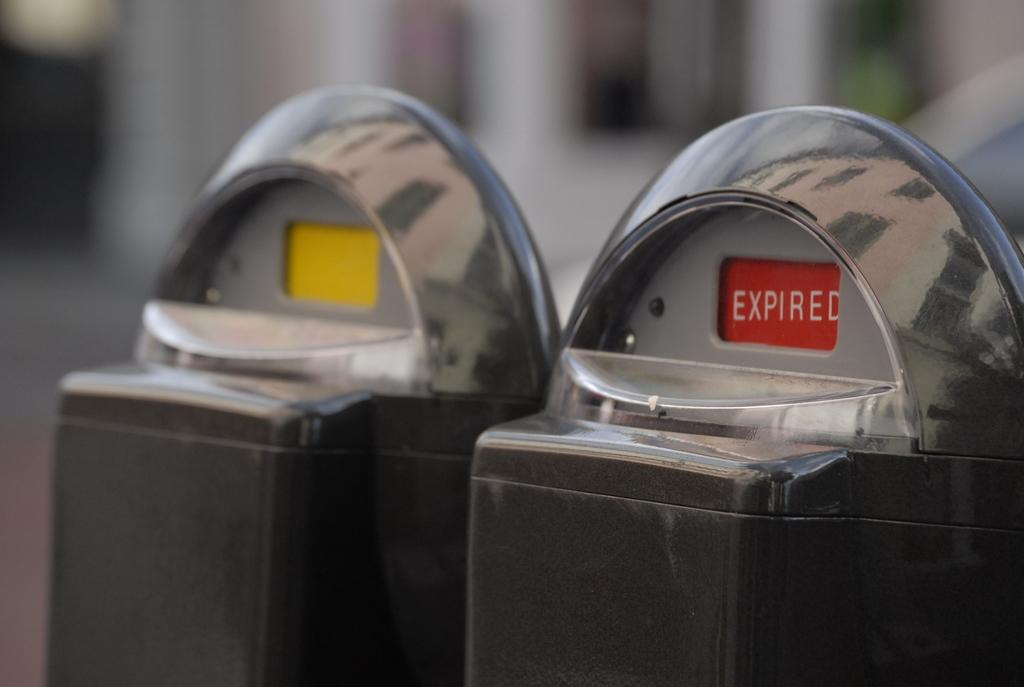<image>
Render a clear and concise summary of the photo. Two parking meters side by side one has a red expired sign on it. 